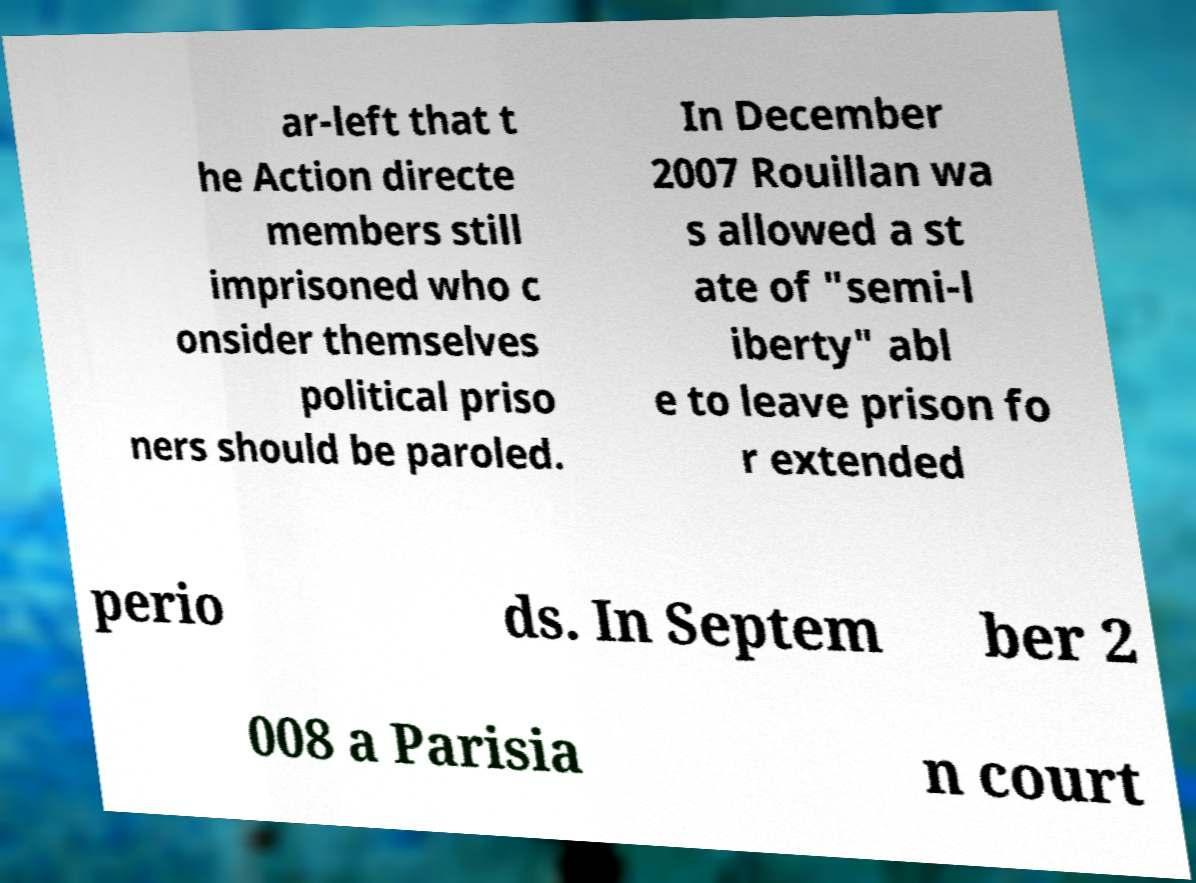For documentation purposes, I need the text within this image transcribed. Could you provide that? ar-left that t he Action directe members still imprisoned who c onsider themselves political priso ners should be paroled. In December 2007 Rouillan wa s allowed a st ate of "semi-l iberty" abl e to leave prison fo r extended perio ds. In Septem ber 2 008 a Parisia n court 